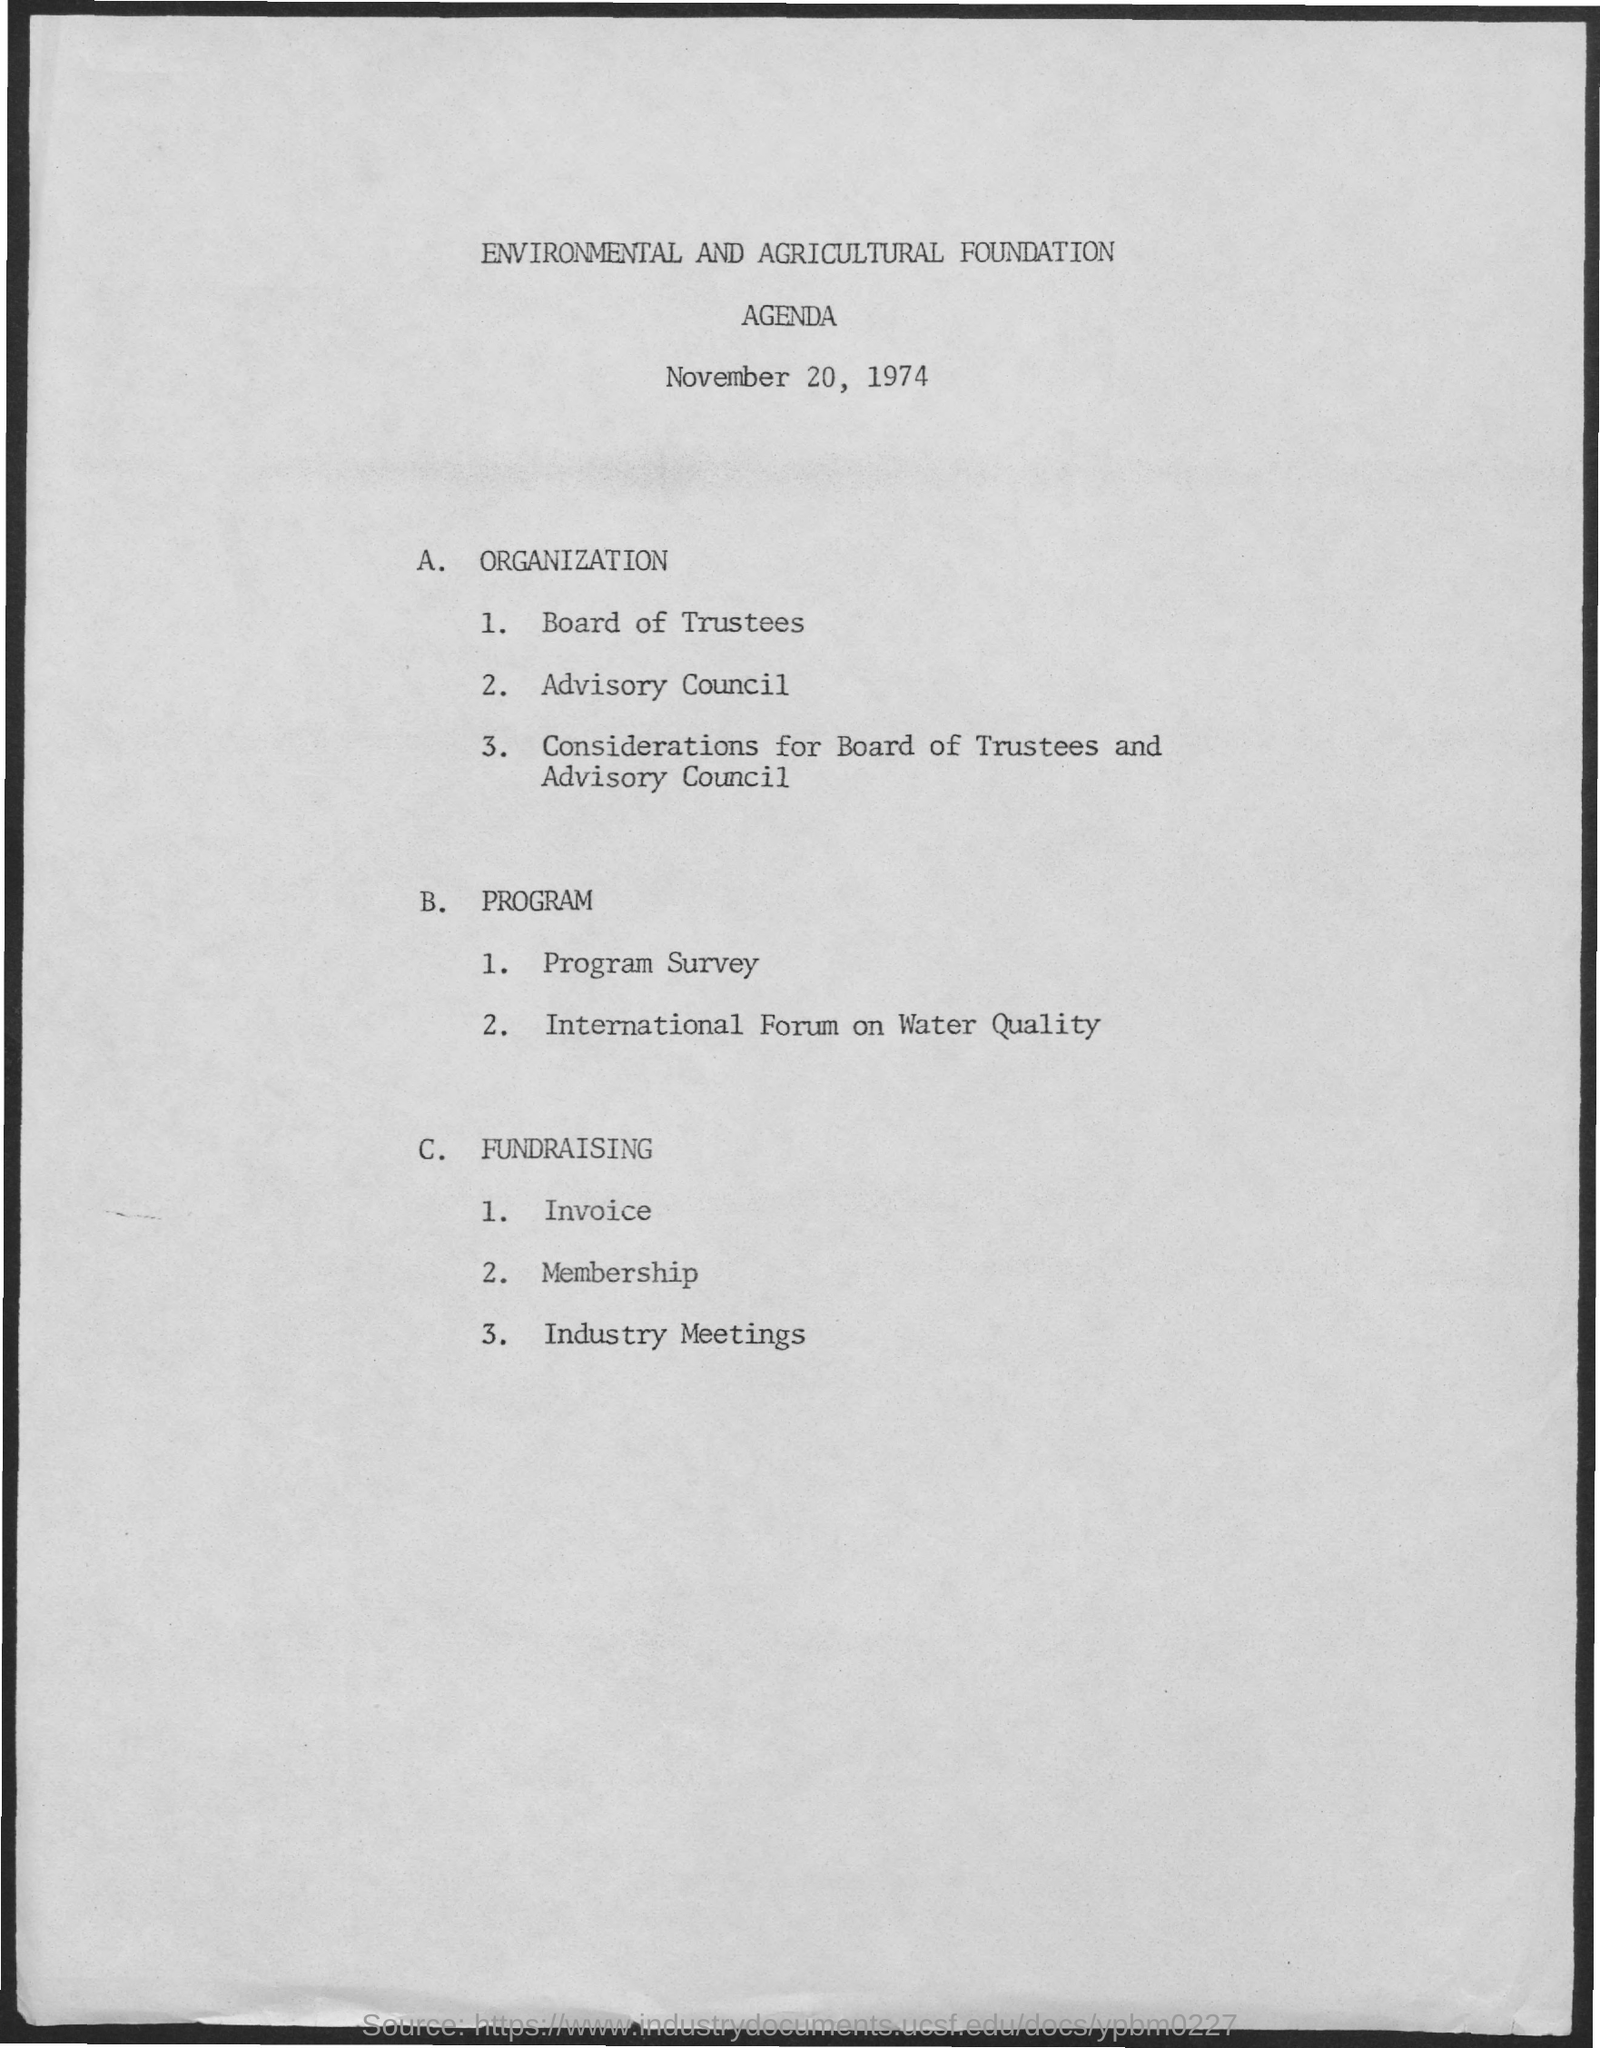What is the date on the document?
Your answer should be very brief. November 20, 1974. What is the Title of the document?
Ensure brevity in your answer.  Environmental and Agricultural Foundation Agenda. 